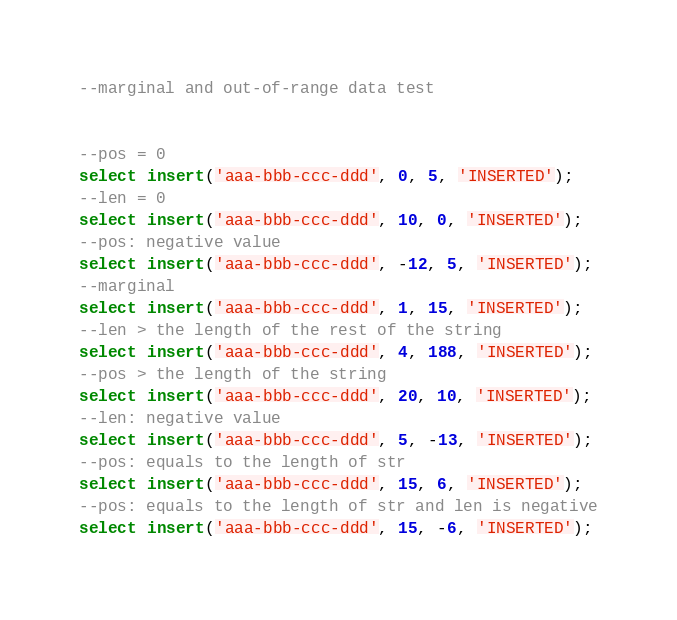Convert code to text. <code><loc_0><loc_0><loc_500><loc_500><_SQL_>--marginal and out-of-range data test


--pos = 0
select insert('aaa-bbb-ccc-ddd', 0, 5, 'INSERTED');
--len = 0
select insert('aaa-bbb-ccc-ddd', 10, 0, 'INSERTED');
--pos: negative value
select insert('aaa-bbb-ccc-ddd', -12, 5, 'INSERTED');
--marginal
select insert('aaa-bbb-ccc-ddd', 1, 15, 'INSERTED');
--len > the length of the rest of the string
select insert('aaa-bbb-ccc-ddd', 4, 188, 'INSERTED');
--pos > the length of the string
select insert('aaa-bbb-ccc-ddd', 20, 10, 'INSERTED');
--len: negative value
select insert('aaa-bbb-ccc-ddd', 5, -13, 'INSERTED');
--pos: equals to the length of str
select insert('aaa-bbb-ccc-ddd', 15, 6, 'INSERTED');
--pos: equals to the length of str and len is negative
select insert('aaa-bbb-ccc-ddd', 15, -6, 'INSERTED');

</code> 